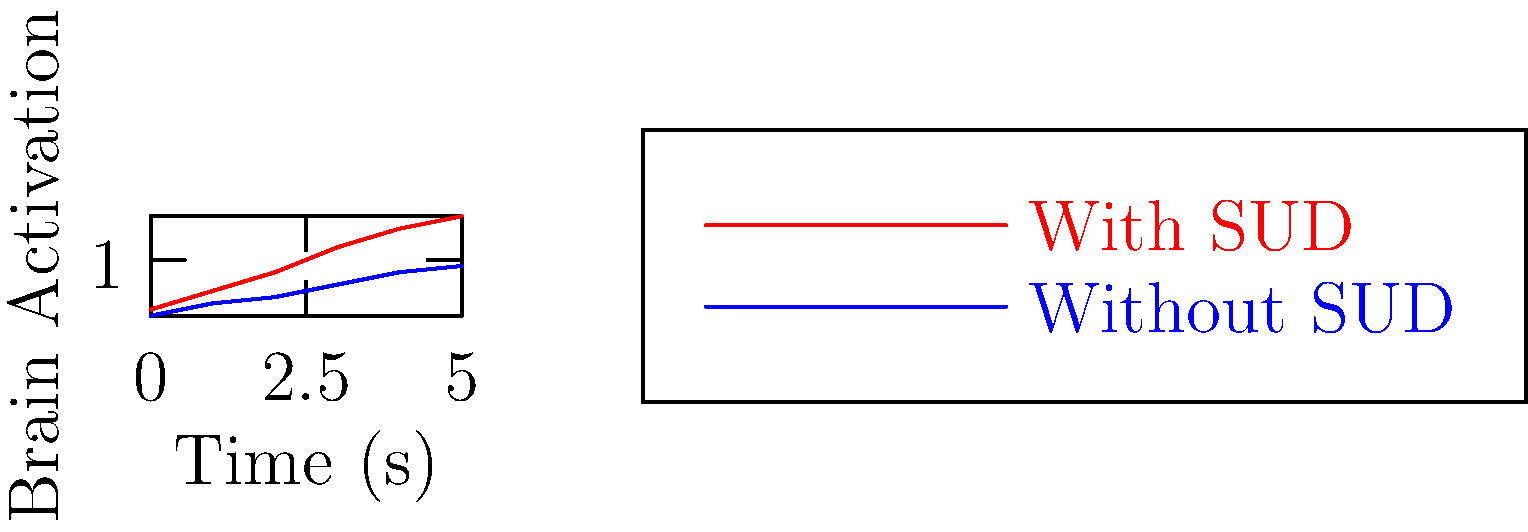Based on the fMRI brain activation patterns shown in the graph, which group demonstrates a higher overall level of brain activation over time, and what might this suggest about the neural processes in individuals with substance use disorders (SUDs)? 1. Analyze the graph:
   - Red line represents individuals with SUDs
   - Blue line represents individuals without SUDs
   - X-axis shows time in seconds
   - Y-axis shows brain activation level

2. Compare the two lines:
   - The red line (SUD group) consistently shows higher values
   - The blue line (non-SUD group) shows lower values throughout

3. Interpret the differences:
   - Higher activation in the SUD group suggests increased neural activity
   - This could indicate:
     a) Hyperactivation of reward circuits
     b) Altered cognitive control processes
     c) Compensatory mechanisms in response to substance use

4. Consider implications:
   - Higher activation doesn't necessarily mean better function
   - It could represent inefficient or maladaptive neural processes
   - This pattern might be related to craving, impulsivity, or altered decision-making in SUDs

5. Relate to clinical practice:
   - This information could inform treatment approaches
   - It might suggest targets for interventions (e.g., neurofeedback, cognitive training)
   - It underscores the importance of addressing neural alterations in SUD treatment
Answer: Individuals with SUDs show higher brain activation, suggesting altered neural processes potentially related to reward sensitivity, cognitive control, or compensatory mechanisms. 